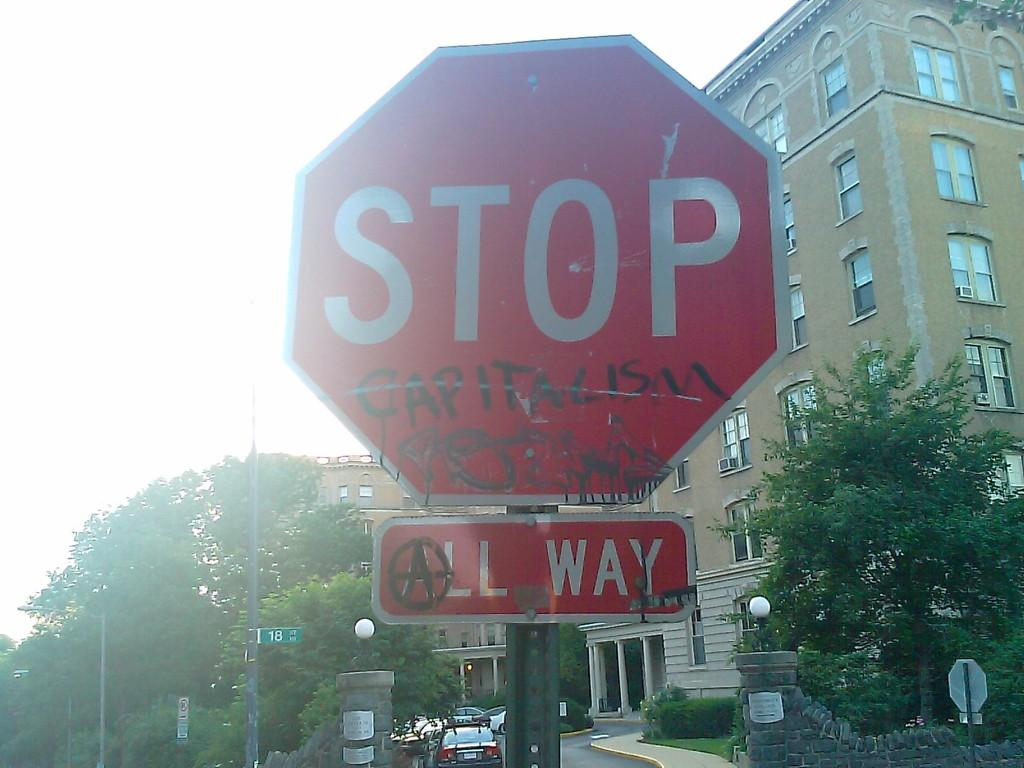Provide a one-sentence caption for the provided image. Stop sign with an All Way sign right below it. 